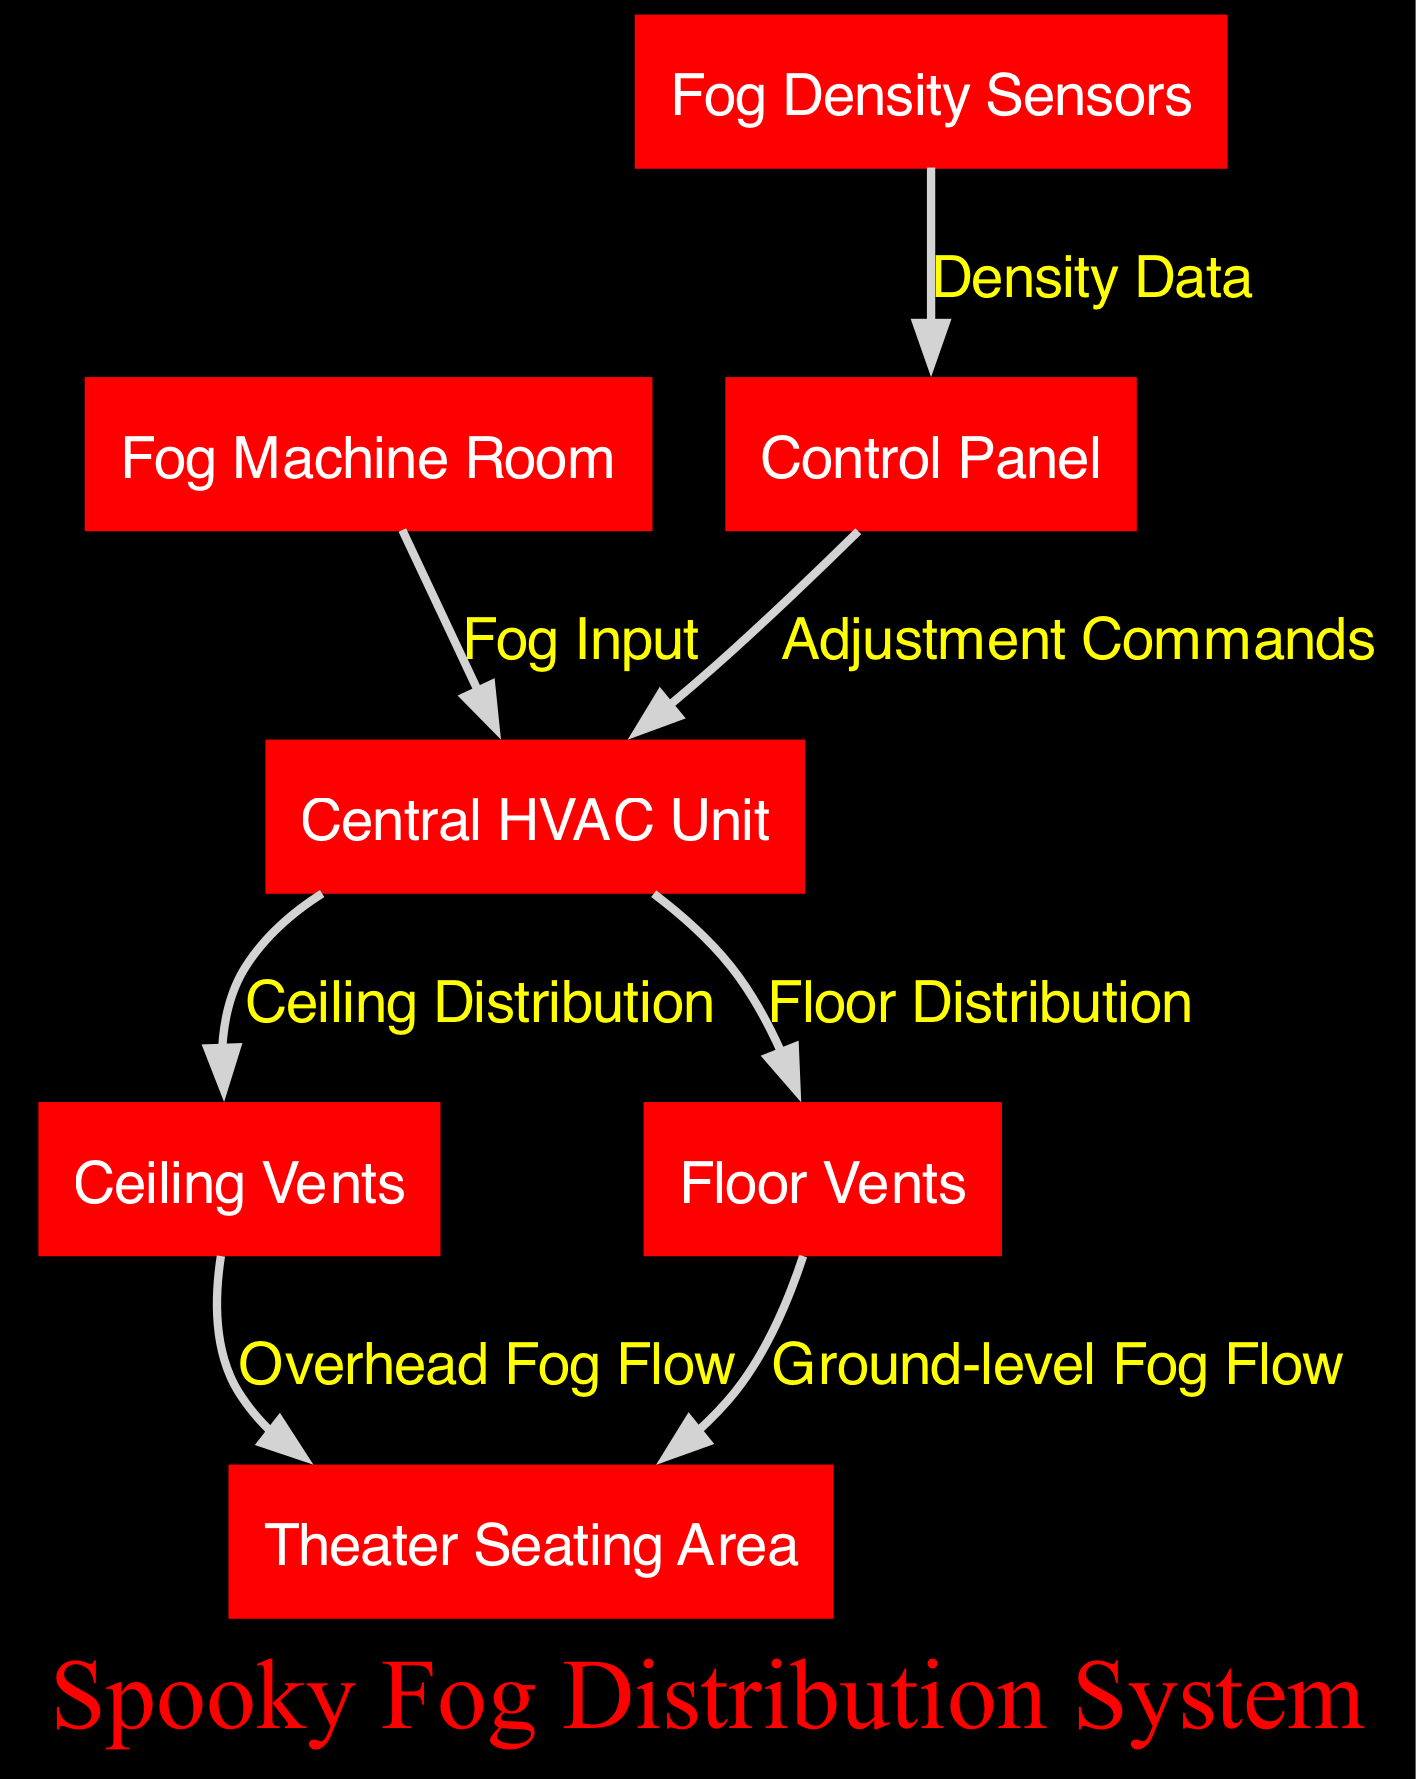What is the total number of nodes in the diagram? The diagram lists 7 distinct nodes, each representing a different component of the fog distribution system. These nodes are the Fog Machine Room, Theater Seating Area, Central HVAC Unit, Ceiling Vents, Floor Vents, Fog Density Sensors, and Control Panel. Thus, counting each one provides the total number of nodes.
Answer: 7 Which two nodes are connected by the "Fog Input" edge? The edge labeled "Fog Input" connects the Fog Machine Room and the Central HVAC Unit. By examining the edges in the diagram, it is clear that this specific label indicates the flow of fog from the machine room to the HVAC unit.
Answer: Fog Machine Room and Central HVAC Unit What does the Central HVAC Unit distribute fog to? The Central HVAC Unit distributes fog to both the Ceiling Vents and the Floor Vents, as indicated by two separate edges leading from the HVAC unit to these vents. This means it has designated pathways for fog distribution at different levels of the theater.
Answer: Ceiling Vents and Floor Vents How many types of fog flow are indicated in the diagram? The diagram indicates two types of fog flow: "Overhead Fog Flow" from the Ceiling Vents to the Theater Seating Area and "Ground-level Fog Flow" from the Floor Vents to the Theater Seating Area. These distinct flows provide a comprehensive system for fog distribution at varying heights.
Answer: 2 What kind of data do the Fog Density Sensors provide to the Control Panel? The Fog Density Sensors provide "Density Data" to the Control Panel. The relationship is shown with a directed edge labeled accordingly, which implies that these sensors monitor the fog density and send that information for processing and adjustments if necessary.
Answer: Density Data Which component receives adjustment commands from the Control Panel? The Control Panel sends adjustment commands to the Central HVAC Unit. The edge connecting these components indicates a feedback loop where the control panel can influence the operation of the HVAC unit based on the fog density detected.
Answer: Central HVAC Unit What flows from the Floor Vents to the Theater Seating Area? The label "Ground-level Fog Flow" describes the fog flowing from the Floor Vents to the Theater Seating Area. This path is specifically marked in the diagram, signifying that fog is directed at ground level for atmospheric effects in the theater.
Answer: Ground-level Fog Flow 